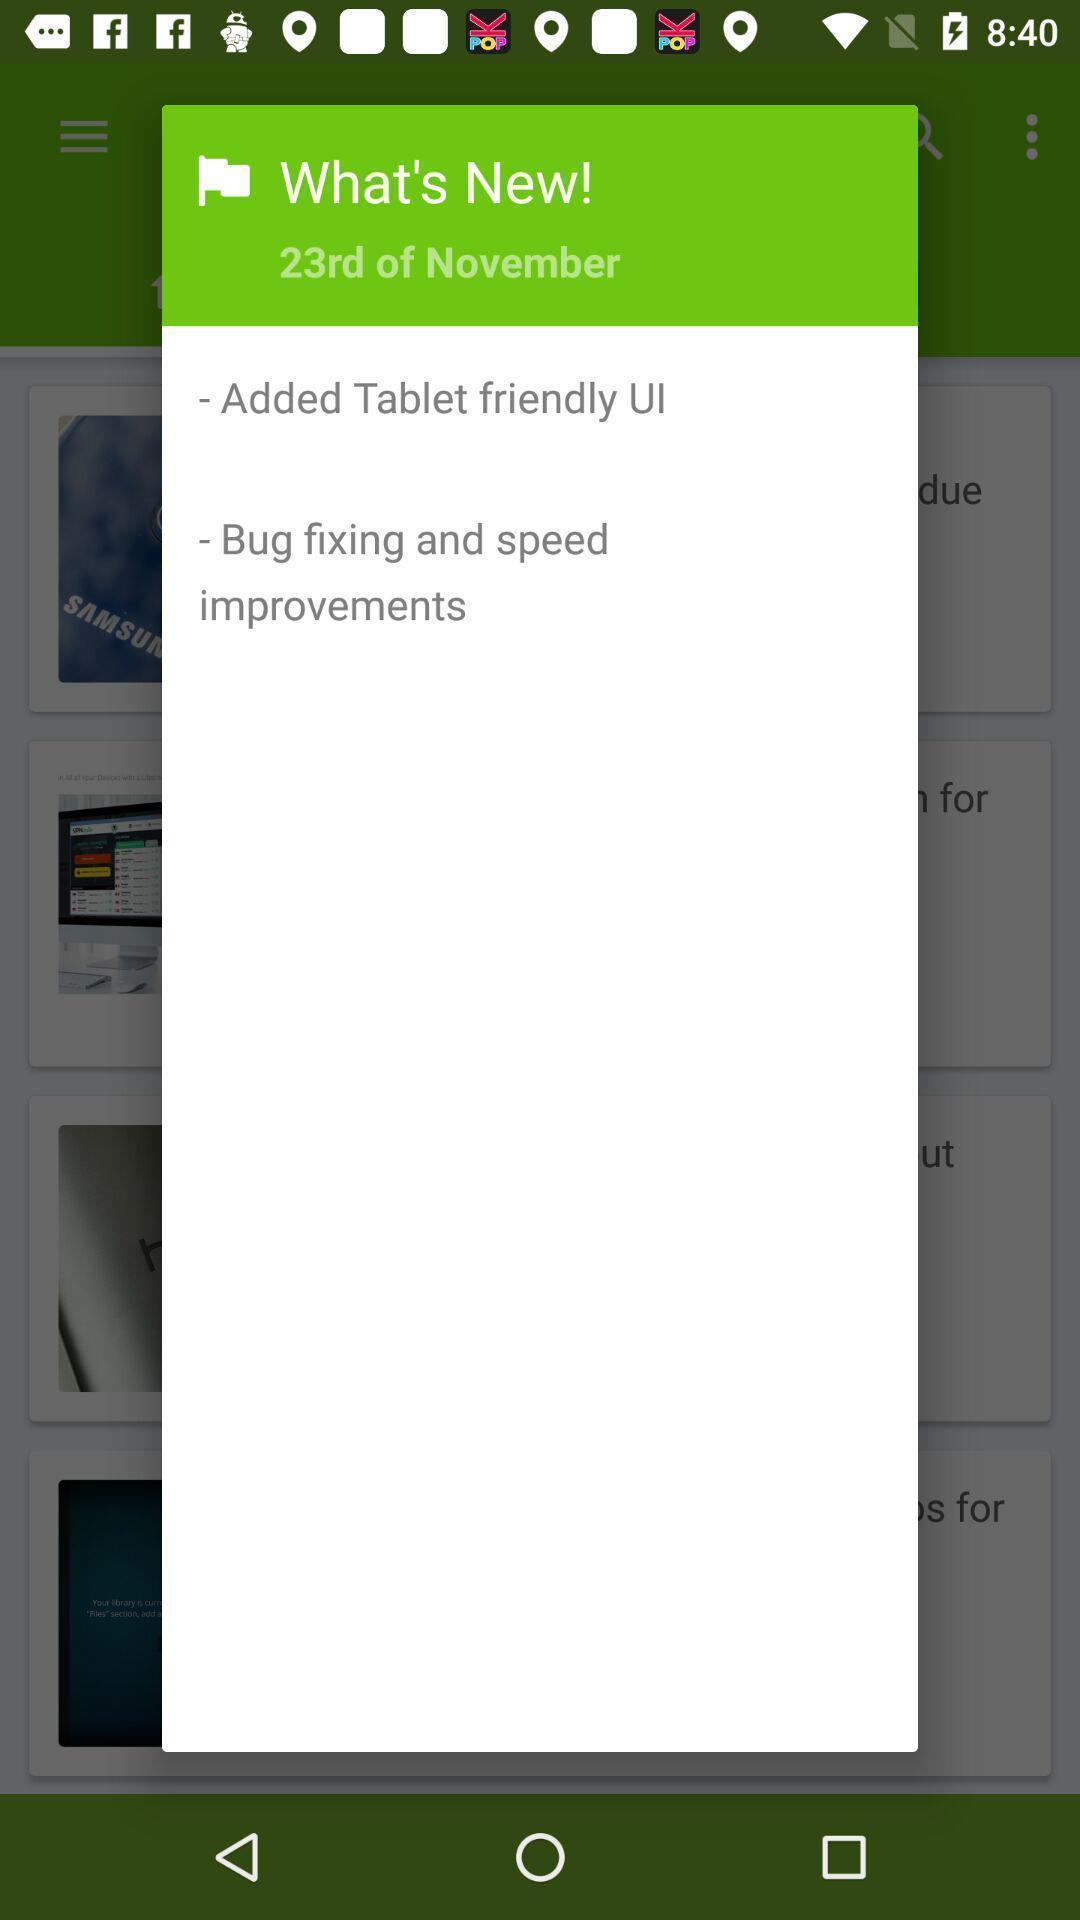Describe the key features of this screenshot. Pop-up showing the different points. 